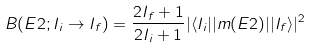Convert formula to latex. <formula><loc_0><loc_0><loc_500><loc_500>B ( E 2 ; I _ { i } \rightarrow I _ { f } ) = \frac { 2 I _ { f } + 1 } { 2 I _ { i } + 1 } | \langle I _ { i } | | m ( E 2 ) | | I _ { f } \rangle | ^ { 2 }</formula> 